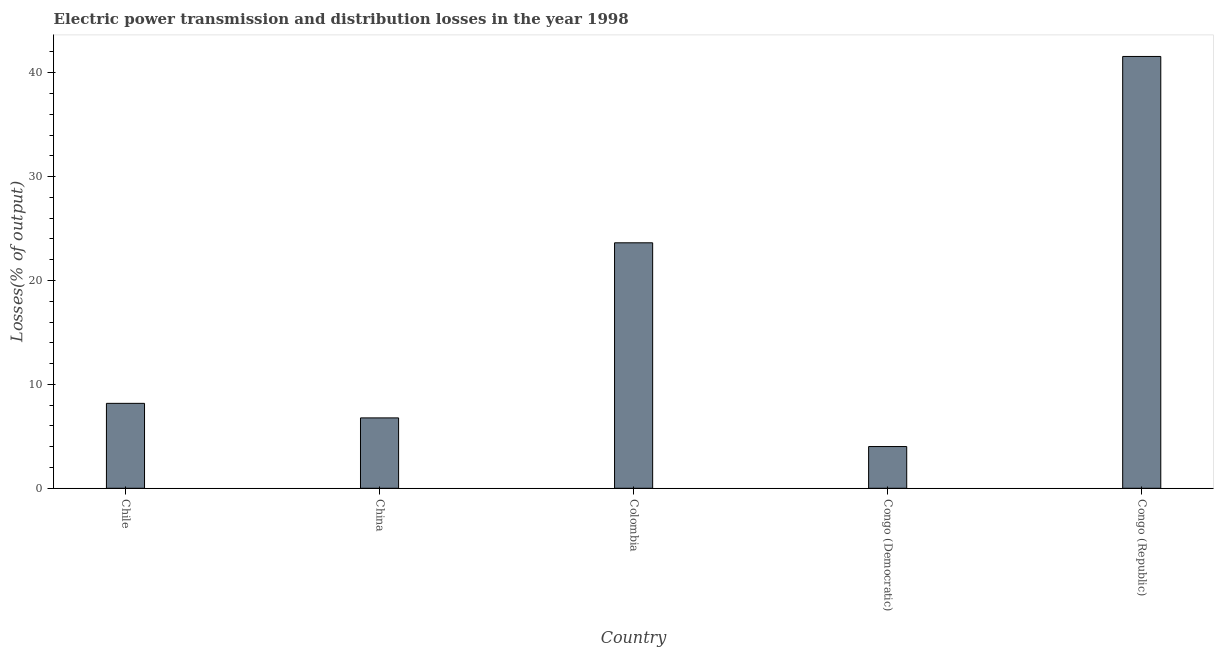What is the title of the graph?
Keep it short and to the point. Electric power transmission and distribution losses in the year 1998. What is the label or title of the X-axis?
Provide a short and direct response. Country. What is the label or title of the Y-axis?
Your answer should be very brief. Losses(% of output). What is the electric power transmission and distribution losses in Chile?
Give a very brief answer. 8.18. Across all countries, what is the maximum electric power transmission and distribution losses?
Give a very brief answer. 41.57. Across all countries, what is the minimum electric power transmission and distribution losses?
Ensure brevity in your answer.  4.02. In which country was the electric power transmission and distribution losses maximum?
Keep it short and to the point. Congo (Republic). In which country was the electric power transmission and distribution losses minimum?
Keep it short and to the point. Congo (Democratic). What is the sum of the electric power transmission and distribution losses?
Ensure brevity in your answer.  84.17. What is the difference between the electric power transmission and distribution losses in Colombia and Congo (Republic)?
Offer a terse response. -17.94. What is the average electric power transmission and distribution losses per country?
Keep it short and to the point. 16.83. What is the median electric power transmission and distribution losses?
Provide a short and direct response. 8.18. In how many countries, is the electric power transmission and distribution losses greater than 16 %?
Offer a terse response. 2. What is the ratio of the electric power transmission and distribution losses in Congo (Democratic) to that in Congo (Republic)?
Offer a terse response. 0.1. What is the difference between the highest and the second highest electric power transmission and distribution losses?
Offer a very short reply. 17.94. What is the difference between the highest and the lowest electric power transmission and distribution losses?
Make the answer very short. 37.55. In how many countries, is the electric power transmission and distribution losses greater than the average electric power transmission and distribution losses taken over all countries?
Provide a succinct answer. 2. Are the values on the major ticks of Y-axis written in scientific E-notation?
Ensure brevity in your answer.  No. What is the Losses(% of output) in Chile?
Keep it short and to the point. 8.18. What is the Losses(% of output) of China?
Provide a succinct answer. 6.78. What is the Losses(% of output) of Colombia?
Keep it short and to the point. 23.63. What is the Losses(% of output) of Congo (Democratic)?
Offer a terse response. 4.02. What is the Losses(% of output) of Congo (Republic)?
Keep it short and to the point. 41.57. What is the difference between the Losses(% of output) in Chile and China?
Offer a very short reply. 1.4. What is the difference between the Losses(% of output) in Chile and Colombia?
Ensure brevity in your answer.  -15.46. What is the difference between the Losses(% of output) in Chile and Congo (Democratic)?
Give a very brief answer. 4.16. What is the difference between the Losses(% of output) in Chile and Congo (Republic)?
Your response must be concise. -33.39. What is the difference between the Losses(% of output) in China and Colombia?
Provide a succinct answer. -16.86. What is the difference between the Losses(% of output) in China and Congo (Democratic)?
Offer a terse response. 2.76. What is the difference between the Losses(% of output) in China and Congo (Republic)?
Provide a short and direct response. -34.79. What is the difference between the Losses(% of output) in Colombia and Congo (Democratic)?
Your answer should be very brief. 19.61. What is the difference between the Losses(% of output) in Colombia and Congo (Republic)?
Ensure brevity in your answer.  -17.94. What is the difference between the Losses(% of output) in Congo (Democratic) and Congo (Republic)?
Provide a succinct answer. -37.55. What is the ratio of the Losses(% of output) in Chile to that in China?
Your answer should be compact. 1.21. What is the ratio of the Losses(% of output) in Chile to that in Colombia?
Provide a succinct answer. 0.35. What is the ratio of the Losses(% of output) in Chile to that in Congo (Democratic)?
Offer a very short reply. 2.03. What is the ratio of the Losses(% of output) in Chile to that in Congo (Republic)?
Give a very brief answer. 0.2. What is the ratio of the Losses(% of output) in China to that in Colombia?
Keep it short and to the point. 0.29. What is the ratio of the Losses(% of output) in China to that in Congo (Democratic)?
Provide a short and direct response. 1.69. What is the ratio of the Losses(% of output) in China to that in Congo (Republic)?
Provide a short and direct response. 0.16. What is the ratio of the Losses(% of output) in Colombia to that in Congo (Democratic)?
Your answer should be very brief. 5.88. What is the ratio of the Losses(% of output) in Colombia to that in Congo (Republic)?
Provide a short and direct response. 0.57. What is the ratio of the Losses(% of output) in Congo (Democratic) to that in Congo (Republic)?
Give a very brief answer. 0.1. 